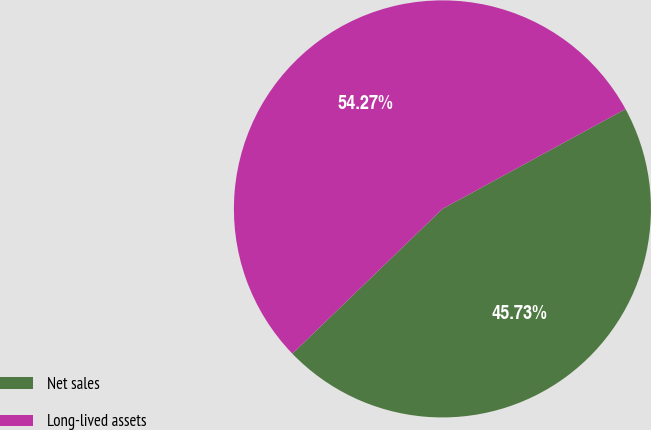<chart> <loc_0><loc_0><loc_500><loc_500><pie_chart><fcel>Net sales<fcel>Long-lived assets<nl><fcel>45.73%<fcel>54.27%<nl></chart> 